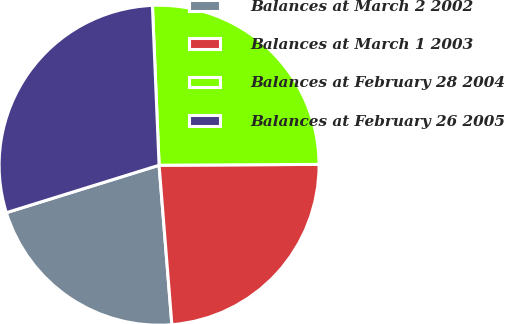<chart> <loc_0><loc_0><loc_500><loc_500><pie_chart><fcel>Balances at March 2 2002<fcel>Balances at March 1 2003<fcel>Balances at February 28 2004<fcel>Balances at February 26 2005<nl><fcel>21.48%<fcel>23.81%<fcel>25.58%<fcel>29.13%<nl></chart> 